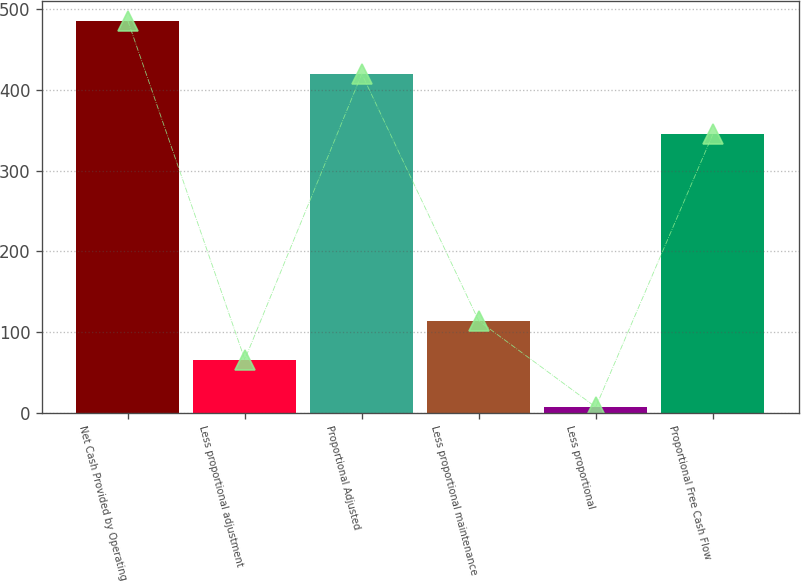Convert chart. <chart><loc_0><loc_0><loc_500><loc_500><bar_chart><fcel>Net Cash Provided by Operating<fcel>Less proportional adjustment<fcel>Proportional Adjusted<fcel>Less proportional maintenance<fcel>Less proportional<fcel>Proportional Free Cash Flow<nl><fcel>486<fcel>66<fcel>420<fcel>113.9<fcel>7<fcel>345<nl></chart> 